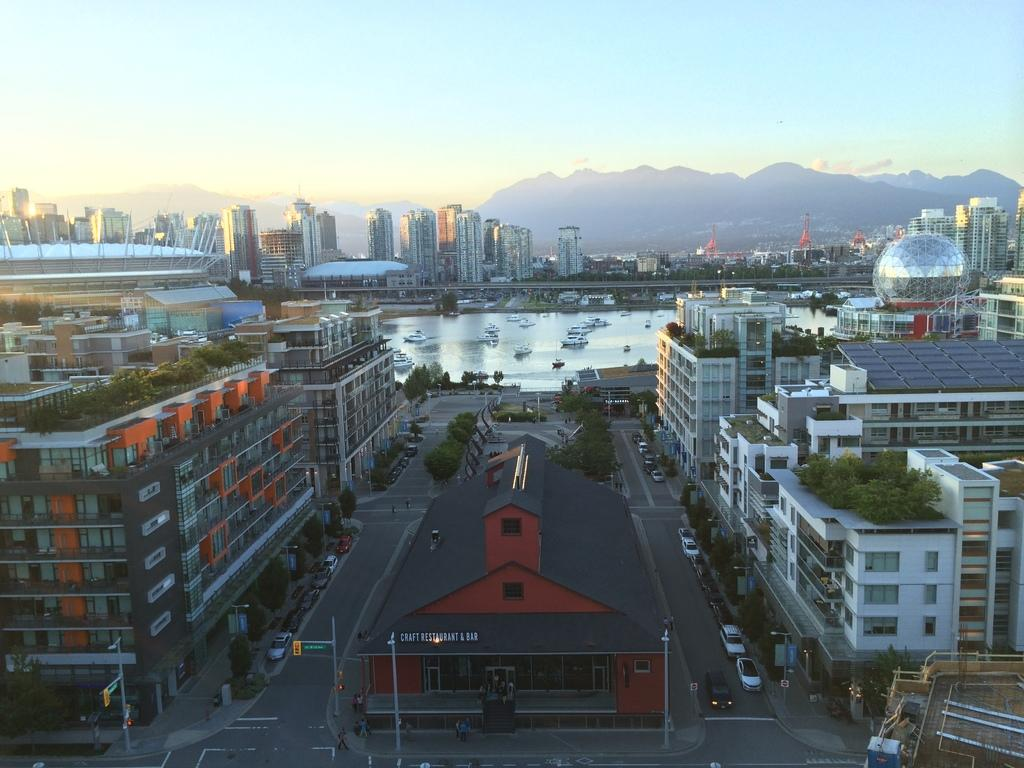What type of view is shown in the image? The image shows an aerial view of a city. What can be seen on the roads in the city? There are many vehicles on the roads. How many buildings are visible in the image? There are many buildings in the city. What is the condition of the sky in the image? The sky is bright in the image. What color is the crayon used to draw the city in the image? There is no crayon present in the image; it is a photograph or digital representation of a city. How does the beginner navigate through the city in the image? There is no indication of a beginner or navigation in the image; it is a static representation of a city. 